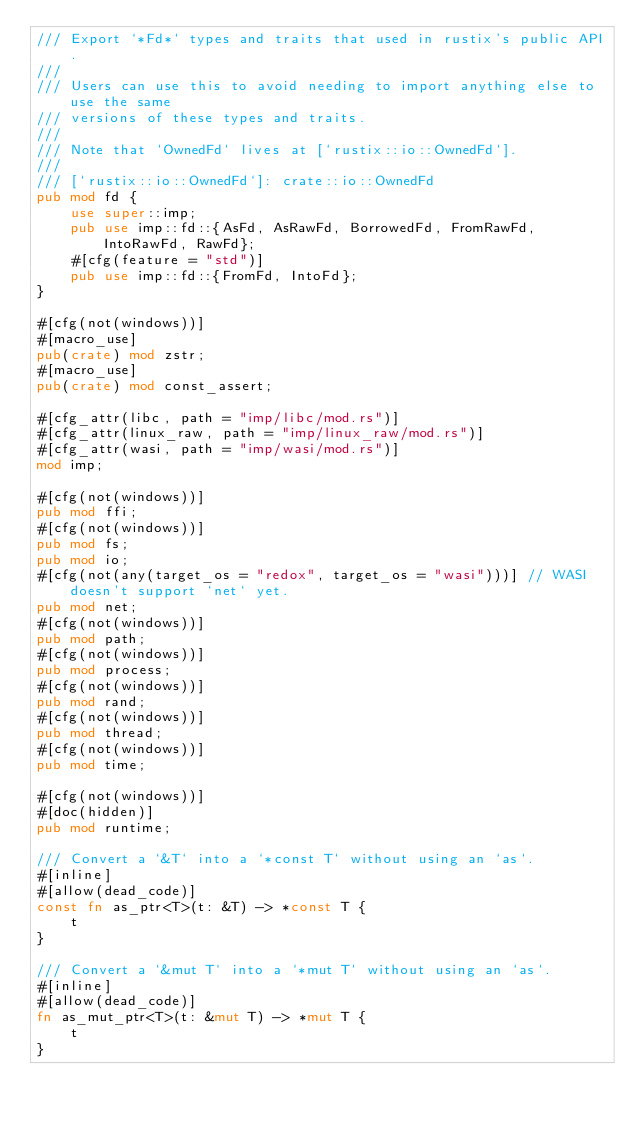Convert code to text. <code><loc_0><loc_0><loc_500><loc_500><_Rust_>/// Export `*Fd*` types and traits that used in rustix's public API.
///
/// Users can use this to avoid needing to import anything else to use the same
/// versions of these types and traits.
///
/// Note that `OwnedFd` lives at [`rustix::io::OwnedFd`].
///
/// [`rustix::io::OwnedFd`]: crate::io::OwnedFd
pub mod fd {
    use super::imp;
    pub use imp::fd::{AsFd, AsRawFd, BorrowedFd, FromRawFd, IntoRawFd, RawFd};
    #[cfg(feature = "std")]
    pub use imp::fd::{FromFd, IntoFd};
}

#[cfg(not(windows))]
#[macro_use]
pub(crate) mod zstr;
#[macro_use]
pub(crate) mod const_assert;

#[cfg_attr(libc, path = "imp/libc/mod.rs")]
#[cfg_attr(linux_raw, path = "imp/linux_raw/mod.rs")]
#[cfg_attr(wasi, path = "imp/wasi/mod.rs")]
mod imp;

#[cfg(not(windows))]
pub mod ffi;
#[cfg(not(windows))]
pub mod fs;
pub mod io;
#[cfg(not(any(target_os = "redox", target_os = "wasi")))] // WASI doesn't support `net` yet.
pub mod net;
#[cfg(not(windows))]
pub mod path;
#[cfg(not(windows))]
pub mod process;
#[cfg(not(windows))]
pub mod rand;
#[cfg(not(windows))]
pub mod thread;
#[cfg(not(windows))]
pub mod time;

#[cfg(not(windows))]
#[doc(hidden)]
pub mod runtime;

/// Convert a `&T` into a `*const T` without using an `as`.
#[inline]
#[allow(dead_code)]
const fn as_ptr<T>(t: &T) -> *const T {
    t
}

/// Convert a `&mut T` into a `*mut T` without using an `as`.
#[inline]
#[allow(dead_code)]
fn as_mut_ptr<T>(t: &mut T) -> *mut T {
    t
}
</code> 